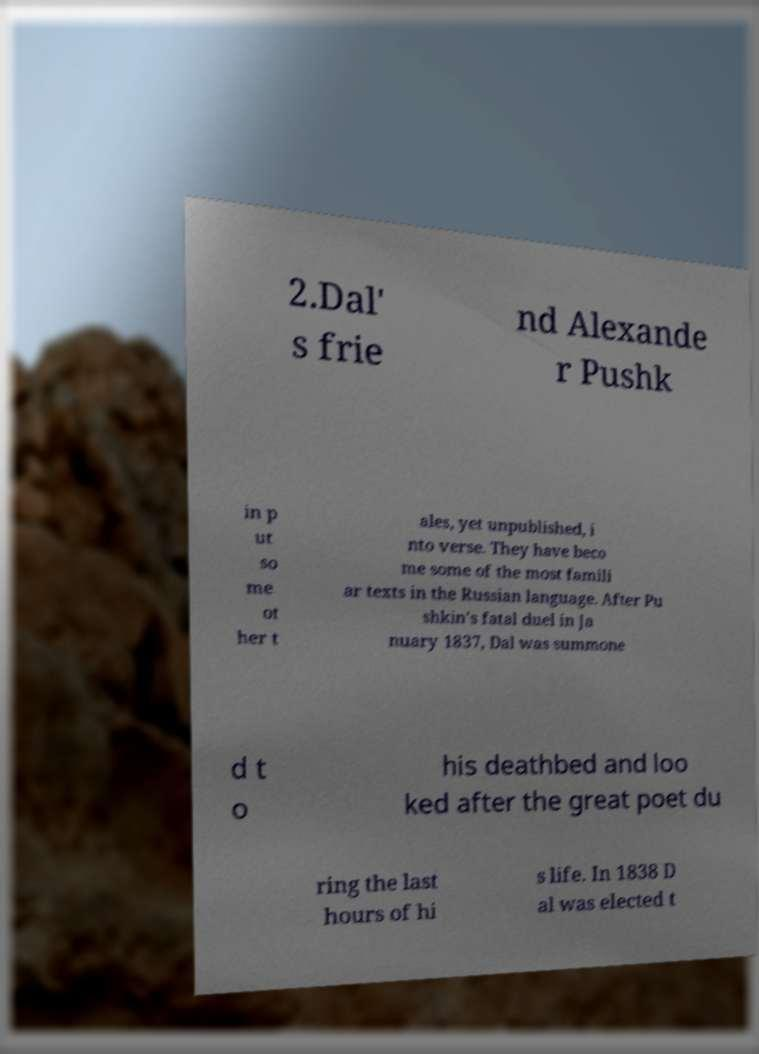Could you assist in decoding the text presented in this image and type it out clearly? 2.Dal' s frie nd Alexande r Pushk in p ut so me ot her t ales, yet unpublished, i nto verse. They have beco me some of the most famili ar texts in the Russian language. After Pu shkin's fatal duel in Ja nuary 1837, Dal was summone d t o his deathbed and loo ked after the great poet du ring the last hours of hi s life. In 1838 D al was elected t 